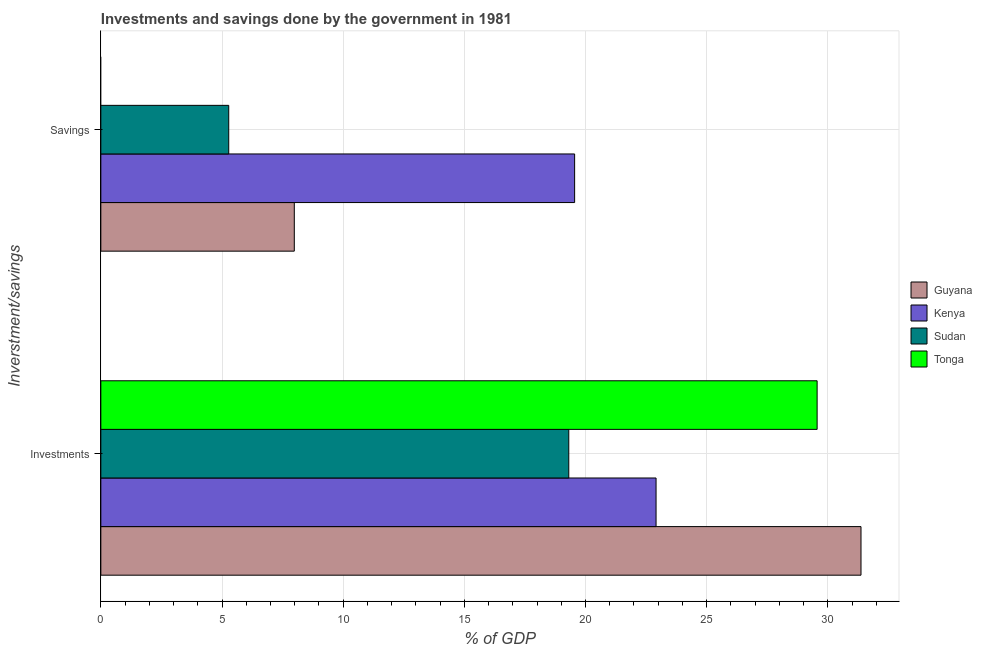How many different coloured bars are there?
Keep it short and to the point. 4. How many bars are there on the 1st tick from the top?
Offer a very short reply. 3. How many bars are there on the 1st tick from the bottom?
Offer a very short reply. 4. What is the label of the 1st group of bars from the top?
Your answer should be compact. Savings. What is the savings of government in Kenya?
Make the answer very short. 19.55. Across all countries, what is the maximum investments of government?
Provide a short and direct response. 31.37. Across all countries, what is the minimum investments of government?
Make the answer very short. 19.31. In which country was the investments of government maximum?
Ensure brevity in your answer.  Guyana. What is the total investments of government in the graph?
Provide a short and direct response. 103.16. What is the difference between the investments of government in Sudan and that in Tonga?
Make the answer very short. -10.25. What is the difference between the savings of government in Guyana and the investments of government in Sudan?
Make the answer very short. -11.33. What is the average investments of government per country?
Your response must be concise. 25.79. What is the difference between the savings of government and investments of government in Kenya?
Provide a short and direct response. -3.36. What is the ratio of the savings of government in Kenya to that in Sudan?
Give a very brief answer. 3.7. In how many countries, is the savings of government greater than the average savings of government taken over all countries?
Offer a terse response. 1. Are all the bars in the graph horizontal?
Provide a short and direct response. Yes. How many countries are there in the graph?
Give a very brief answer. 4. What is the difference between two consecutive major ticks on the X-axis?
Ensure brevity in your answer.  5. Are the values on the major ticks of X-axis written in scientific E-notation?
Provide a succinct answer. No. Does the graph contain grids?
Your answer should be compact. Yes. Where does the legend appear in the graph?
Ensure brevity in your answer.  Center right. What is the title of the graph?
Ensure brevity in your answer.  Investments and savings done by the government in 1981. Does "Singapore" appear as one of the legend labels in the graph?
Ensure brevity in your answer.  No. What is the label or title of the X-axis?
Make the answer very short. % of GDP. What is the label or title of the Y-axis?
Provide a succinct answer. Inverstment/savings. What is the % of GDP in Guyana in Investments?
Provide a short and direct response. 31.37. What is the % of GDP of Kenya in Investments?
Offer a terse response. 22.91. What is the % of GDP of Sudan in Investments?
Provide a succinct answer. 19.31. What is the % of GDP of Tonga in Investments?
Provide a short and direct response. 29.56. What is the % of GDP in Guyana in Savings?
Offer a terse response. 7.98. What is the % of GDP in Kenya in Savings?
Offer a terse response. 19.55. What is the % of GDP of Sudan in Savings?
Give a very brief answer. 5.28. What is the % of GDP of Tonga in Savings?
Provide a succinct answer. 0. Across all Inverstment/savings, what is the maximum % of GDP of Guyana?
Provide a succinct answer. 31.37. Across all Inverstment/savings, what is the maximum % of GDP of Kenya?
Provide a succinct answer. 22.91. Across all Inverstment/savings, what is the maximum % of GDP of Sudan?
Make the answer very short. 19.31. Across all Inverstment/savings, what is the maximum % of GDP in Tonga?
Offer a terse response. 29.56. Across all Inverstment/savings, what is the minimum % of GDP in Guyana?
Ensure brevity in your answer.  7.98. Across all Inverstment/savings, what is the minimum % of GDP of Kenya?
Provide a succinct answer. 19.55. Across all Inverstment/savings, what is the minimum % of GDP in Sudan?
Keep it short and to the point. 5.28. Across all Inverstment/savings, what is the minimum % of GDP in Tonga?
Ensure brevity in your answer.  0. What is the total % of GDP in Guyana in the graph?
Offer a very short reply. 39.35. What is the total % of GDP of Kenya in the graph?
Provide a succinct answer. 42.47. What is the total % of GDP of Sudan in the graph?
Provide a short and direct response. 24.59. What is the total % of GDP of Tonga in the graph?
Provide a succinct answer. 29.56. What is the difference between the % of GDP in Guyana in Investments and that in Savings?
Keep it short and to the point. 23.39. What is the difference between the % of GDP of Kenya in Investments and that in Savings?
Offer a terse response. 3.36. What is the difference between the % of GDP in Sudan in Investments and that in Savings?
Offer a terse response. 14.03. What is the difference between the % of GDP in Guyana in Investments and the % of GDP in Kenya in Savings?
Provide a short and direct response. 11.82. What is the difference between the % of GDP of Guyana in Investments and the % of GDP of Sudan in Savings?
Your response must be concise. 26.09. What is the difference between the % of GDP in Kenya in Investments and the % of GDP in Sudan in Savings?
Offer a terse response. 17.64. What is the average % of GDP of Guyana per Inverstment/savings?
Offer a terse response. 19.68. What is the average % of GDP in Kenya per Inverstment/savings?
Provide a short and direct response. 21.23. What is the average % of GDP of Sudan per Inverstment/savings?
Offer a terse response. 12.29. What is the average % of GDP in Tonga per Inverstment/savings?
Offer a very short reply. 14.78. What is the difference between the % of GDP in Guyana and % of GDP in Kenya in Investments?
Ensure brevity in your answer.  8.46. What is the difference between the % of GDP of Guyana and % of GDP of Sudan in Investments?
Make the answer very short. 12.06. What is the difference between the % of GDP of Guyana and % of GDP of Tonga in Investments?
Your answer should be very brief. 1.81. What is the difference between the % of GDP in Kenya and % of GDP in Sudan in Investments?
Your response must be concise. 3.6. What is the difference between the % of GDP of Kenya and % of GDP of Tonga in Investments?
Keep it short and to the point. -6.65. What is the difference between the % of GDP of Sudan and % of GDP of Tonga in Investments?
Make the answer very short. -10.25. What is the difference between the % of GDP in Guyana and % of GDP in Kenya in Savings?
Offer a very short reply. -11.57. What is the difference between the % of GDP of Guyana and % of GDP of Sudan in Savings?
Offer a very short reply. 2.71. What is the difference between the % of GDP in Kenya and % of GDP in Sudan in Savings?
Give a very brief answer. 14.28. What is the ratio of the % of GDP of Guyana in Investments to that in Savings?
Offer a terse response. 3.93. What is the ratio of the % of GDP in Kenya in Investments to that in Savings?
Offer a terse response. 1.17. What is the ratio of the % of GDP in Sudan in Investments to that in Savings?
Provide a short and direct response. 3.66. What is the difference between the highest and the second highest % of GDP in Guyana?
Your response must be concise. 23.39. What is the difference between the highest and the second highest % of GDP of Kenya?
Provide a short and direct response. 3.36. What is the difference between the highest and the second highest % of GDP in Sudan?
Your answer should be compact. 14.03. What is the difference between the highest and the lowest % of GDP of Guyana?
Offer a terse response. 23.39. What is the difference between the highest and the lowest % of GDP of Kenya?
Your answer should be compact. 3.36. What is the difference between the highest and the lowest % of GDP of Sudan?
Make the answer very short. 14.03. What is the difference between the highest and the lowest % of GDP in Tonga?
Ensure brevity in your answer.  29.56. 